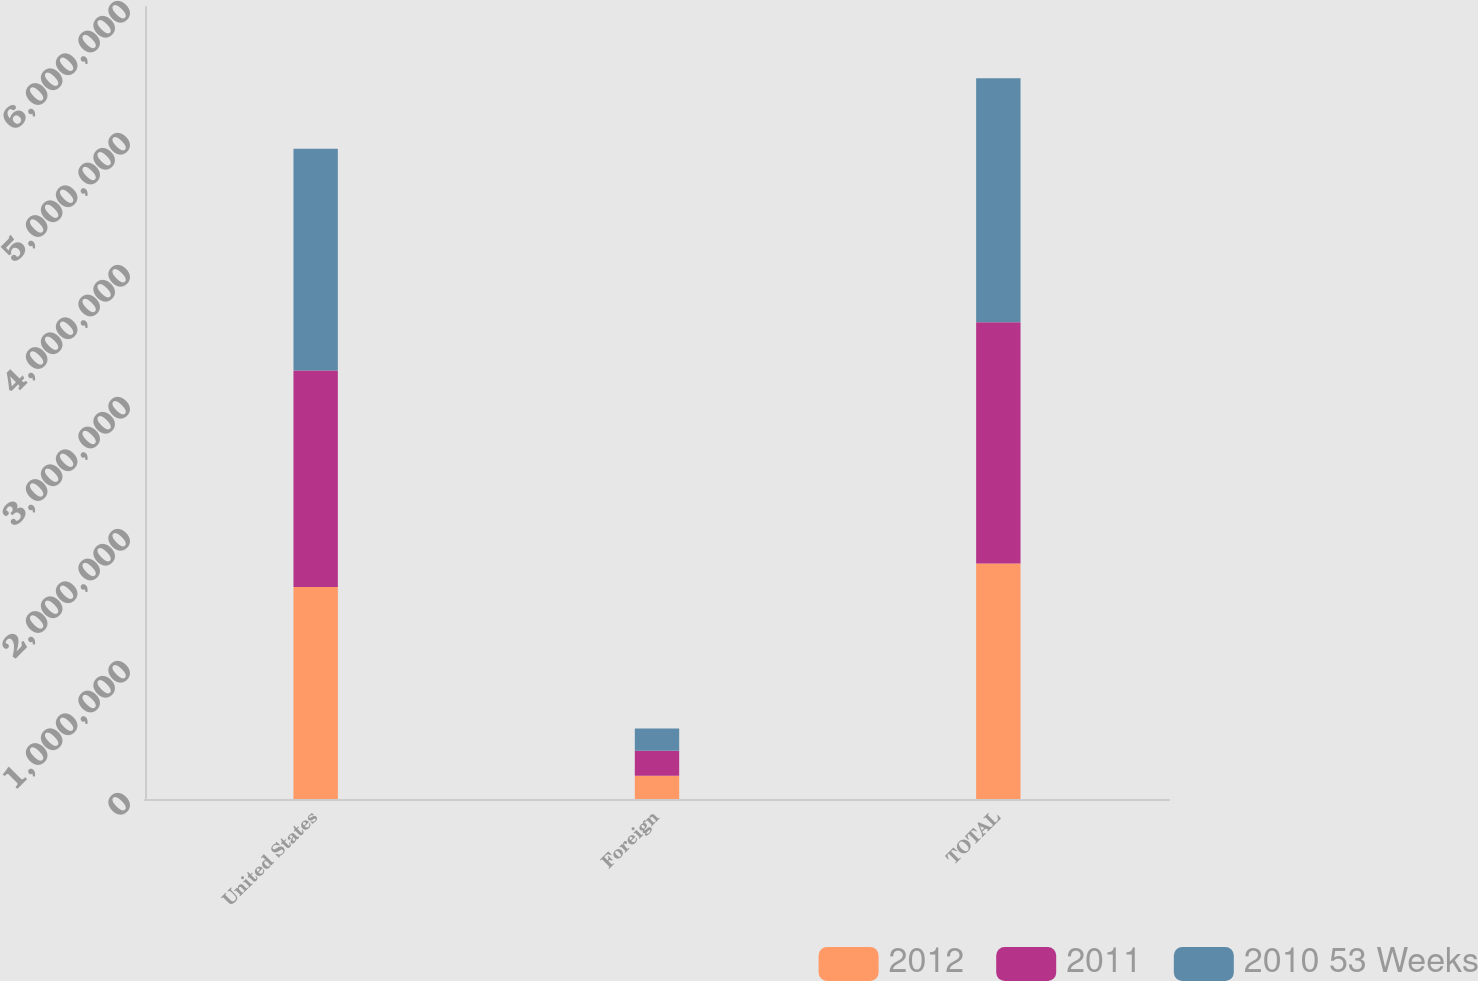Convert chart. <chart><loc_0><loc_0><loc_500><loc_500><stacked_bar_chart><ecel><fcel>United States<fcel>Foreign<fcel>TOTAL<nl><fcel>2012<fcel>1.60693e+06<fcel>177074<fcel>1.784e+06<nl><fcel>2011<fcel>1.63926e+06<fcel>188196<fcel>1.82745e+06<nl><fcel>2010 53 Weeks<fcel>1.67987e+06<fcel>169722<fcel>1.84959e+06<nl></chart> 